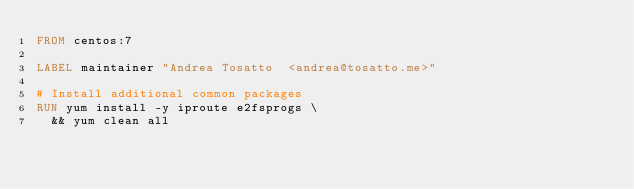Convert code to text. <code><loc_0><loc_0><loc_500><loc_500><_Dockerfile_>FROM centos:7

LABEL maintainer "Andrea Tosatto  <andrea@tosatto.me>"

# Install additional common packages 
RUN yum install -y iproute e2fsprogs \
  && yum clean all
</code> 